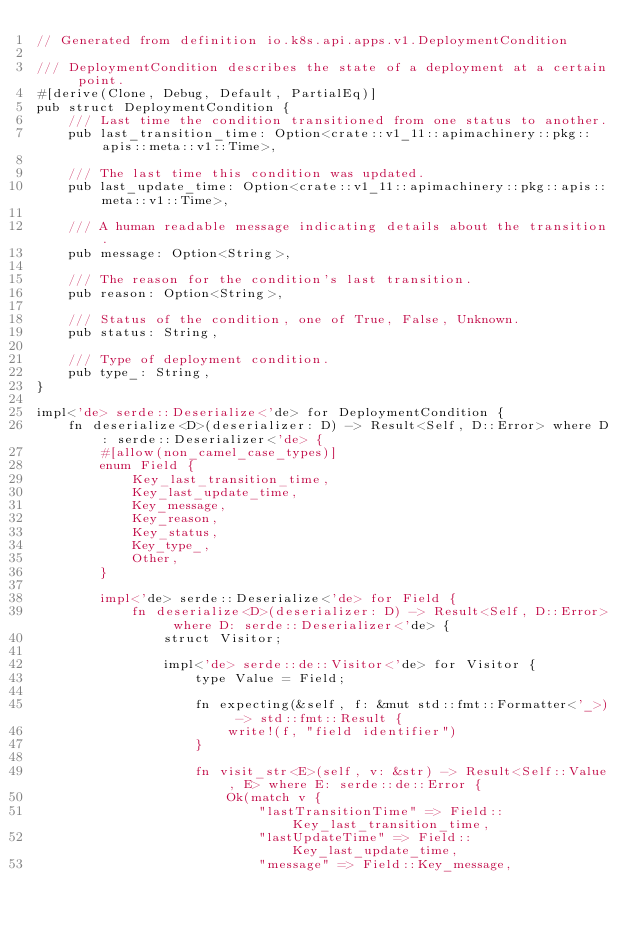<code> <loc_0><loc_0><loc_500><loc_500><_Rust_>// Generated from definition io.k8s.api.apps.v1.DeploymentCondition

/// DeploymentCondition describes the state of a deployment at a certain point.
#[derive(Clone, Debug, Default, PartialEq)]
pub struct DeploymentCondition {
    /// Last time the condition transitioned from one status to another.
    pub last_transition_time: Option<crate::v1_11::apimachinery::pkg::apis::meta::v1::Time>,

    /// The last time this condition was updated.
    pub last_update_time: Option<crate::v1_11::apimachinery::pkg::apis::meta::v1::Time>,

    /// A human readable message indicating details about the transition.
    pub message: Option<String>,

    /// The reason for the condition's last transition.
    pub reason: Option<String>,

    /// Status of the condition, one of True, False, Unknown.
    pub status: String,

    /// Type of deployment condition.
    pub type_: String,
}

impl<'de> serde::Deserialize<'de> for DeploymentCondition {
    fn deserialize<D>(deserializer: D) -> Result<Self, D::Error> where D: serde::Deserializer<'de> {
        #[allow(non_camel_case_types)]
        enum Field {
            Key_last_transition_time,
            Key_last_update_time,
            Key_message,
            Key_reason,
            Key_status,
            Key_type_,
            Other,
        }

        impl<'de> serde::Deserialize<'de> for Field {
            fn deserialize<D>(deserializer: D) -> Result<Self, D::Error> where D: serde::Deserializer<'de> {
                struct Visitor;

                impl<'de> serde::de::Visitor<'de> for Visitor {
                    type Value = Field;

                    fn expecting(&self, f: &mut std::fmt::Formatter<'_>) -> std::fmt::Result {
                        write!(f, "field identifier")
                    }

                    fn visit_str<E>(self, v: &str) -> Result<Self::Value, E> where E: serde::de::Error {
                        Ok(match v {
                            "lastTransitionTime" => Field::Key_last_transition_time,
                            "lastUpdateTime" => Field::Key_last_update_time,
                            "message" => Field::Key_message,</code> 